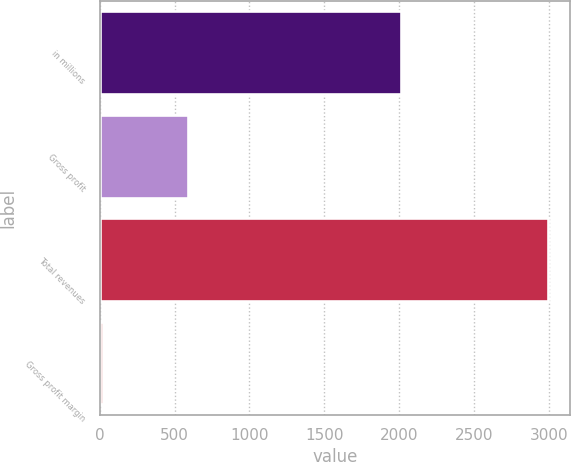<chart> <loc_0><loc_0><loc_500><loc_500><bar_chart><fcel>in millions<fcel>Gross profit<fcel>Total revenues<fcel>Gross profit margin<nl><fcel>2014<fcel>587.6<fcel>2994.2<fcel>19.6<nl></chart> 